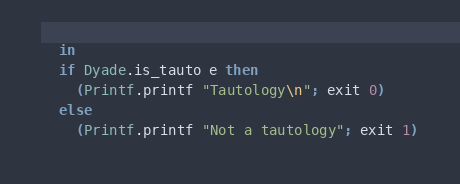Convert code to text. <code><loc_0><loc_0><loc_500><loc_500><_OCaml_>  in 
  if Dyade.is_tauto e then
    (Printf.printf "Tautology\n"; exit 0)
  else
    (Printf.printf "Not a tautology"; exit 1)

</code> 